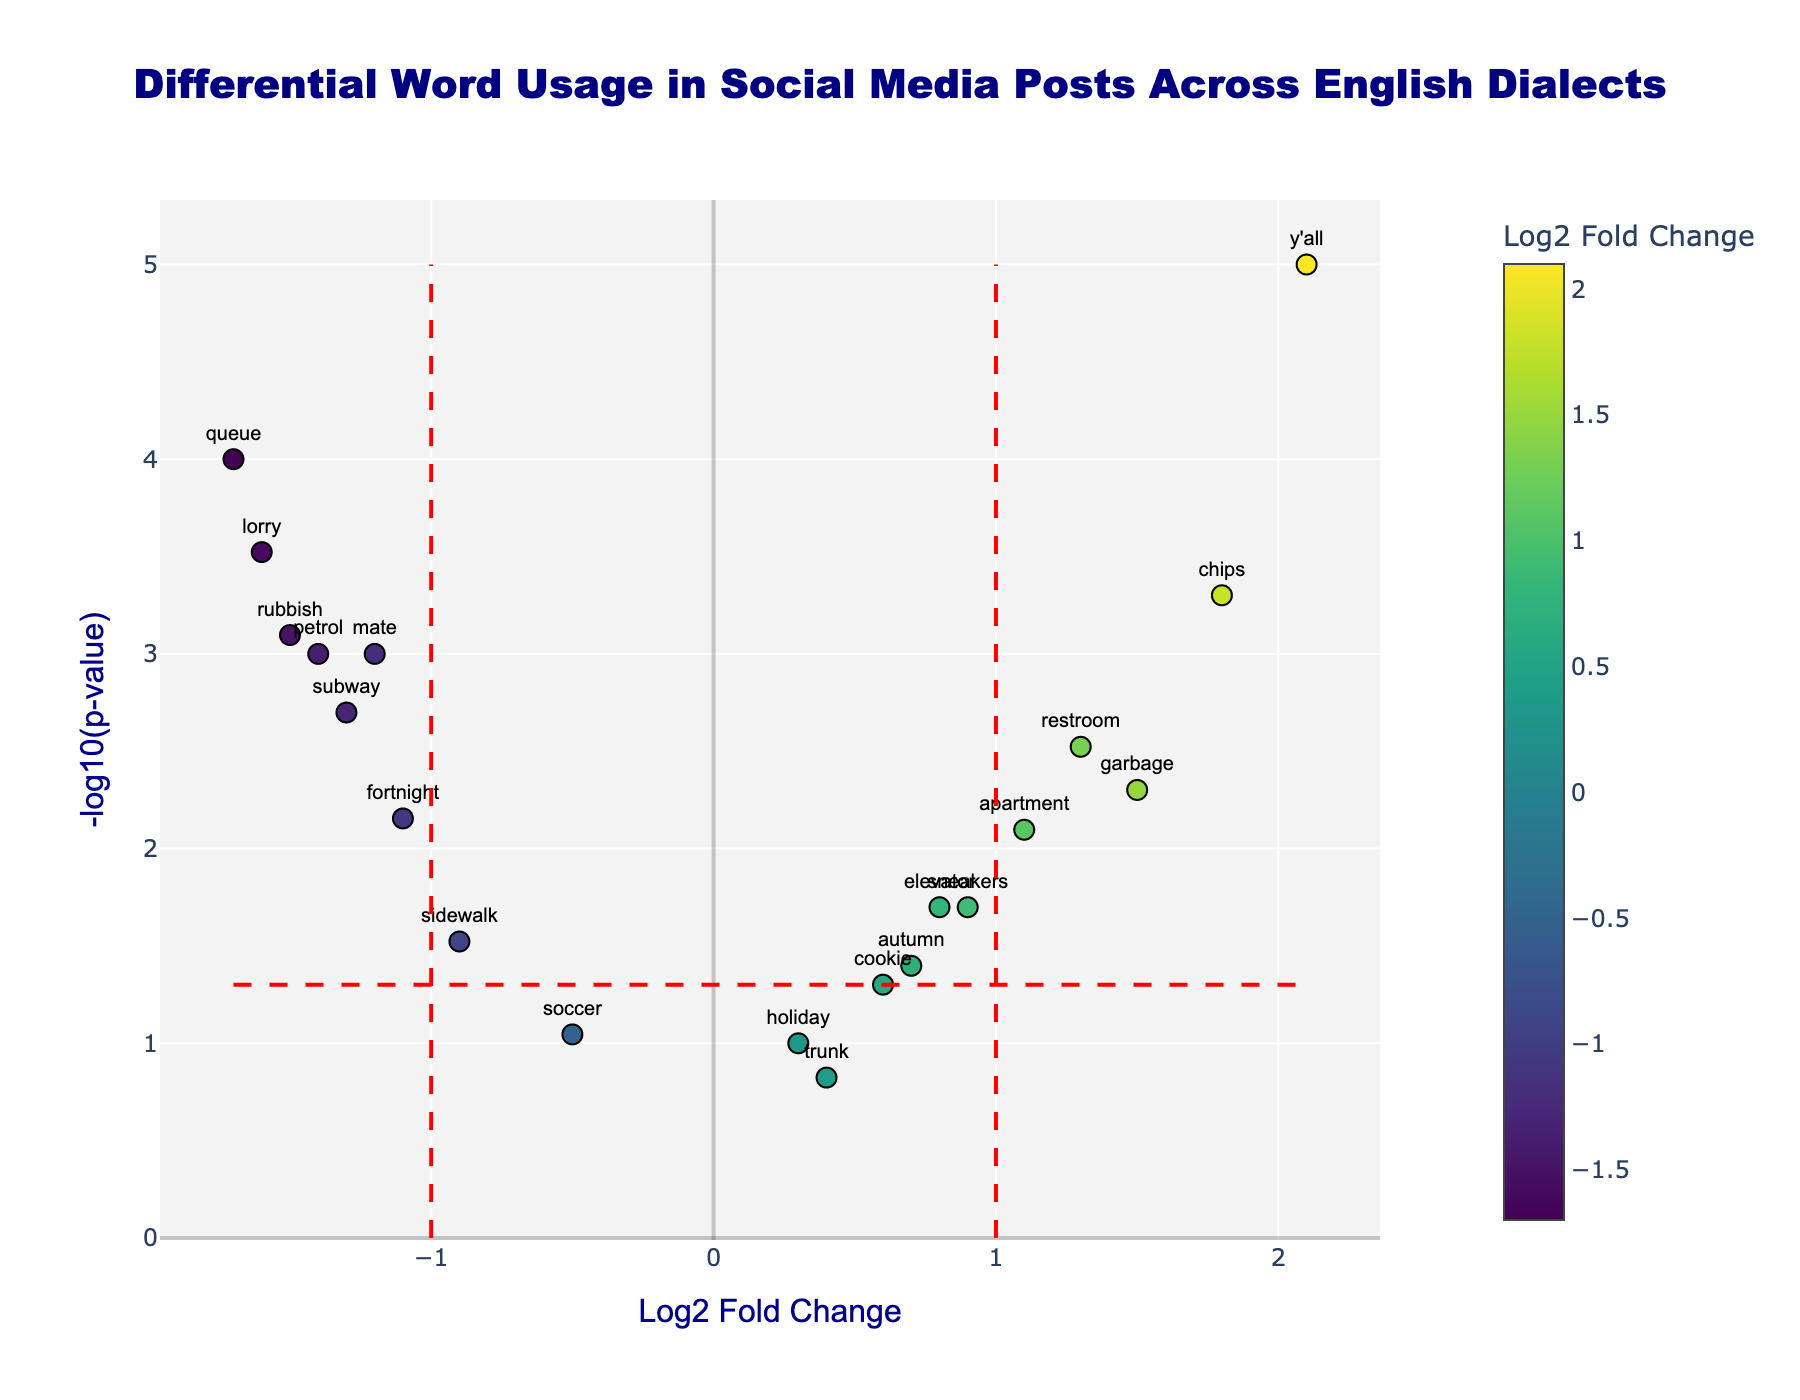What does the title of the figure indicate? The title indicates that the figure displays the differential word usage in social media posts across various English dialects. Specifically, it shows how certain words are used more or less frequently in different dialects by plotting log2 fold changes against the -log10 of p-values.
Answer: Differential Word Usage in Social Media Posts Across English Dialects How many words have a p-value less than 0.05? Words with a p-value less than 0.05 will have a -log10(p-value) greater than -log10(0.05) (approximately 1.3). By counting the points above this threshold, we get 14 words that satisfy this condition.
Answer: 14 Which word has the highest log2 fold change? To find the word with the highest log2 fold change, look for the highest value on the x-axis. The highest point is at log2 fold change of 2.1, associated with the word "y'all".
Answer: y'all What is the log2 fold change and p-value of the word "mate"? Locate the word "mate" on the plot and refer to its hover text or position. "mate" has a log2 fold change of -1.2 and a p-value of 0.001.
Answer: -1.2 and 0.001 What is the significance level (threshold) for the p-value in this Volcano Plot? The significance level can be deduced from the horizontal red dashed line, which corresponds to a p-value of 0.05. The -log10(p-value) threshold is -log10(0.05), approximately 1.3.
Answer: 0.05 Which words have the most substantial evidence against the null hypothesis? Words with the smallest p-values (largest -log10(p-values)) have the most evidence against the null hypothesis. By identifying the highest points on the y-axis, "y'all" and "queue" have the largest -log10(p-values).
Answer: y'all and queue Compare the log2 fold changes of "subway" and "apartment". Which one is higher? Locate both "subway" and "apartment" on the plot. "subway" has a log2 fold change of -1.3, whereas "apartment" has a log2 fold change of 1.1. Since 1.1 is greater than -1.3, "apartment" has a higher log2 fold change.
Answer: apartment Which words fall outside the vertical fold change thresholds of -1 and 1? Words outside the vertical red dashed lines at log2 fold changes of -1 and 1 are "queue", "petrol", "lorry", and "rubbish" to the left and "y'all" and "chips" to the right.
Answer: queue, petrol, lorry, rubbish, y'all, and chips What does a positive log2 fold change indicate in this context? A positive log2 fold change indicates that the respective word is used more frequently in the dialect on the right side of the comparison than the one on the left side. Conversely, a negative log2 fold change means the word is used more frequently in the dialect on the left side.
Answer: More frequently in the right dialect Which words have a log2 fold change close to zero? Words with log2 fold changes close to zero will be near the y-axis. "holiday" and "trunk" have log2 fold changes of 0.3 and 0.4, respectively, making them close to zero.
Answer: holiday and trunk 